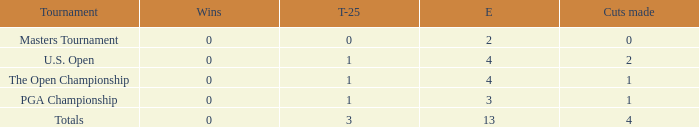How many cuts made in the tournament he played 13 times? None. 